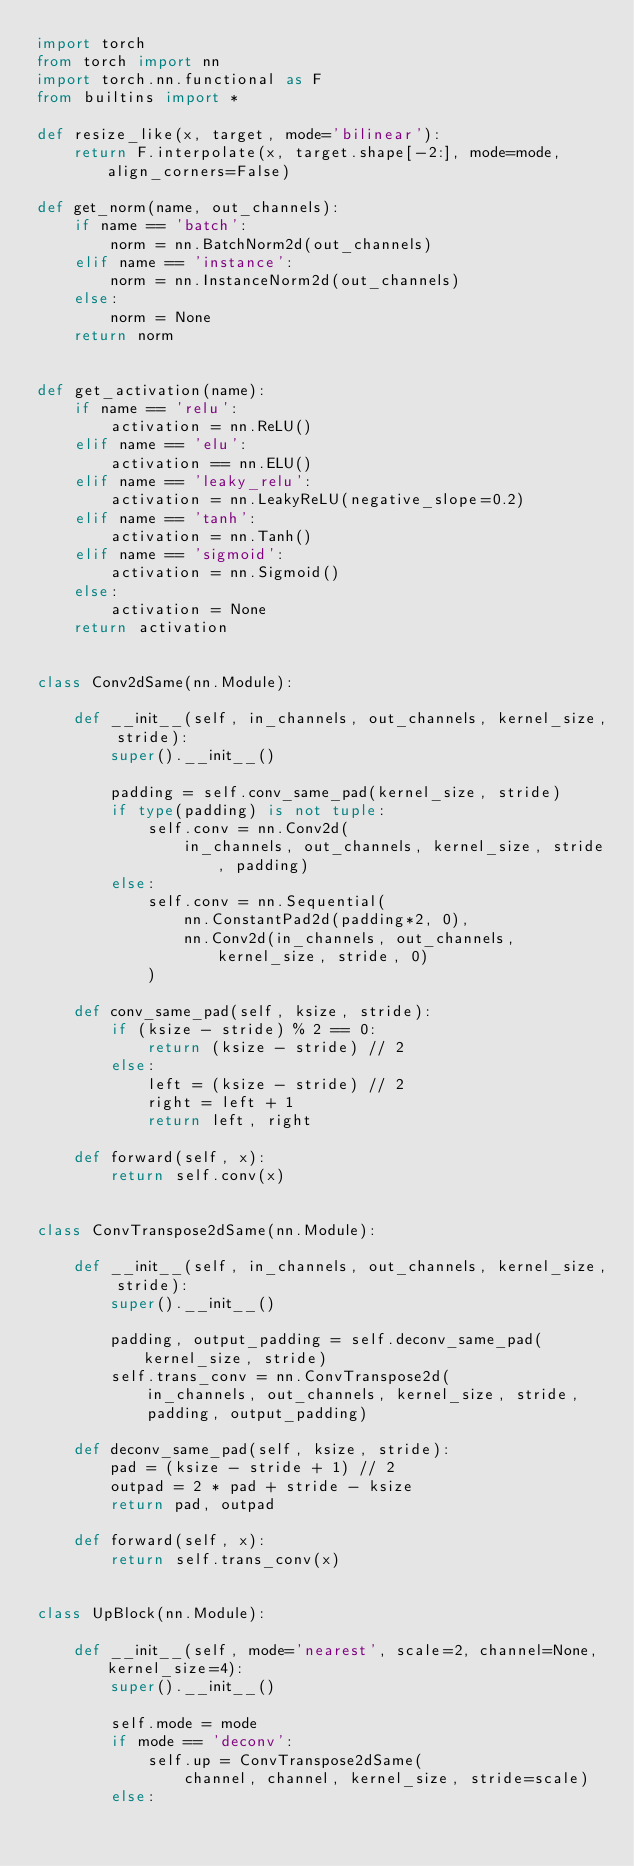Convert code to text. <code><loc_0><loc_0><loc_500><loc_500><_Python_>import torch
from torch import nn
import torch.nn.functional as F
from builtins import *

def resize_like(x, target, mode='bilinear'):
    return F.interpolate(x, target.shape[-2:], mode=mode, align_corners=False)

def get_norm(name, out_channels):
    if name == 'batch':
        norm = nn.BatchNorm2d(out_channels)
    elif name == 'instance':
        norm = nn.InstanceNorm2d(out_channels)
    else:
        norm = None
    return norm


def get_activation(name):
    if name == 'relu':
        activation = nn.ReLU()
    elif name == 'elu':
        activation == nn.ELU()
    elif name == 'leaky_relu':
        activation = nn.LeakyReLU(negative_slope=0.2)
    elif name == 'tanh':
        activation = nn.Tanh()
    elif name == 'sigmoid':
        activation = nn.Sigmoid()
    else:
        activation = None
    return activation


class Conv2dSame(nn.Module):

    def __init__(self, in_channels, out_channels, kernel_size, stride):
        super().__init__()

        padding = self.conv_same_pad(kernel_size, stride)
        if type(padding) is not tuple:
            self.conv = nn.Conv2d(
                in_channels, out_channels, kernel_size, stride, padding)
        else:
            self.conv = nn.Sequential(
                nn.ConstantPad2d(padding*2, 0),
                nn.Conv2d(in_channels, out_channels, kernel_size, stride, 0)
            )

    def conv_same_pad(self, ksize, stride):
        if (ksize - stride) % 2 == 0:
            return (ksize - stride) // 2
        else:
            left = (ksize - stride) // 2
            right = left + 1
            return left, right

    def forward(self, x):
        return self.conv(x)


class ConvTranspose2dSame(nn.Module):

    def __init__(self, in_channels, out_channels, kernel_size, stride):
        super().__init__()

        padding, output_padding = self.deconv_same_pad(kernel_size, stride)
        self.trans_conv = nn.ConvTranspose2d(
            in_channels, out_channels, kernel_size, stride,
            padding, output_padding)

    def deconv_same_pad(self, ksize, stride):
        pad = (ksize - stride + 1) // 2
        outpad = 2 * pad + stride - ksize
        return pad, outpad

    def forward(self, x):
        return self.trans_conv(x)


class UpBlock(nn.Module):

    def __init__(self, mode='nearest', scale=2, channel=None, kernel_size=4):
        super().__init__()

        self.mode = mode
        if mode == 'deconv':
            self.up = ConvTranspose2dSame(
                channel, channel, kernel_size, stride=scale)
        else:</code> 